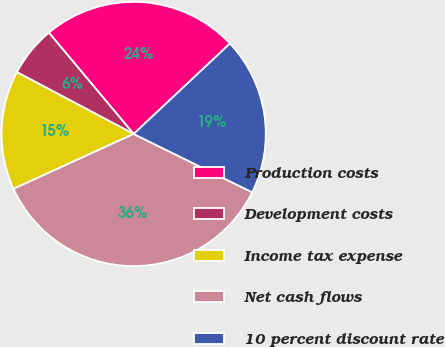Convert chart to OTSL. <chart><loc_0><loc_0><loc_500><loc_500><pie_chart><fcel>Production costs<fcel>Development costs<fcel>Income tax expense<fcel>Net cash flows<fcel>10 percent discount rate<nl><fcel>24.09%<fcel>6.16%<fcel>14.57%<fcel>35.9%<fcel>19.28%<nl></chart> 